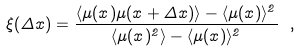<formula> <loc_0><loc_0><loc_500><loc_500>\xi ( \Delta x ) = \frac { \langle \mu ( x ) \mu ( x + \Delta x ) \rangle - \langle \mu ( x ) \rangle ^ { 2 } } { \langle \mu ( x ) ^ { 2 } \rangle - \langle \mu ( x ) \rangle ^ { 2 } } \ ,</formula> 